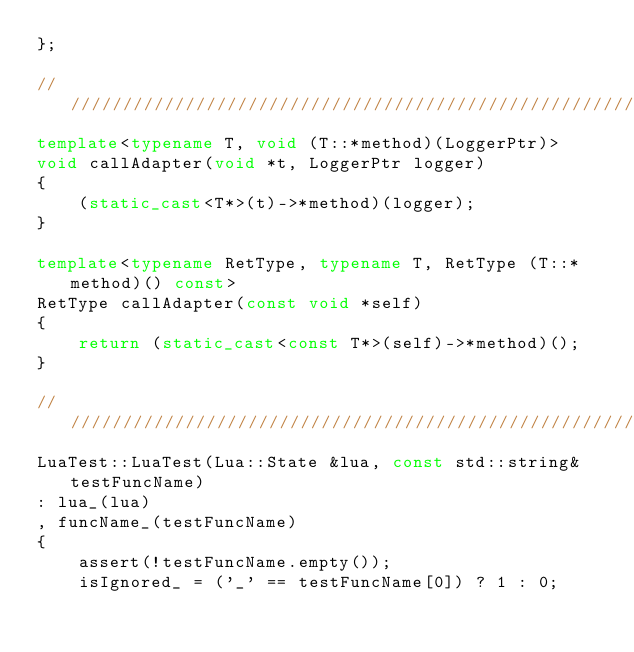Convert code to text. <code><loc_0><loc_0><loc_500><loc_500><_C++_>};

//////////////////////////////////////////////////////////////////////////////////////////////////////////////
template<typename T, void (T::*method)(LoggerPtr)>
void callAdapter(void *t, LoggerPtr logger)
{
    (static_cast<T*>(t)->*method)(logger);
}

template<typename RetType, typename T, RetType (T::*method)() const>
RetType callAdapter(const void *self)
{
    return (static_cast<const T*>(self)->*method)();
}

//////////////////////////////////////////////////////////////////////////////////////////////////////////////
LuaTest::LuaTest(Lua::State &lua, const std::string& testFuncName)
: lua_(lua)
, funcName_(testFuncName)
{
    assert(!testFuncName.empty());
    isIgnored_ = ('_' == testFuncName[0]) ? 1 : 0;
    </code> 